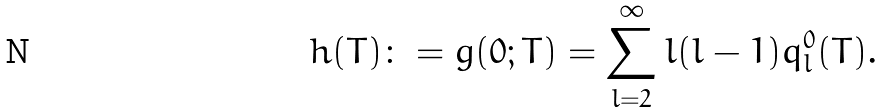Convert formula to latex. <formula><loc_0><loc_0><loc_500><loc_500>h ( T ) \colon = g ( 0 ; T ) = \sum _ { l = 2 } ^ { \infty } l ( l - 1 ) q _ { l } ^ { 0 } ( T ) .</formula> 